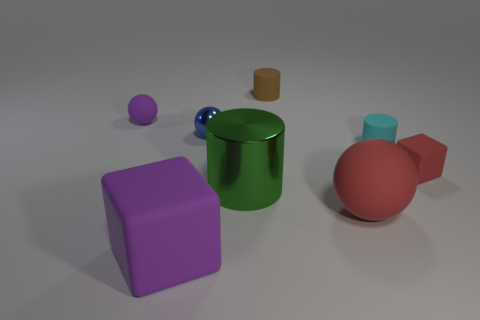Subtract all blocks. How many objects are left? 6 Add 2 purple metal things. How many objects exist? 10 Subtract all cyan things. Subtract all purple rubber objects. How many objects are left? 5 Add 1 large shiny cylinders. How many large shiny cylinders are left? 2 Add 7 shiny objects. How many shiny objects exist? 9 Subtract 1 purple cubes. How many objects are left? 7 